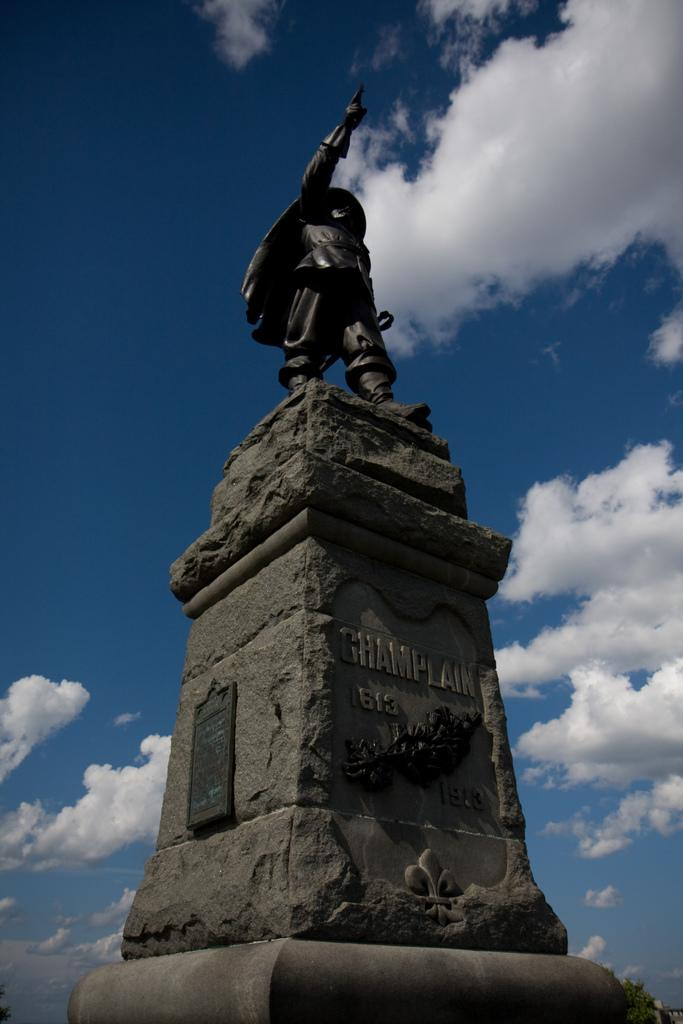What is the main subject in the center of the image? There is a statue in the center of the image. What can be seen in the background of the image? There is a sky visible in the background of the image. What is the condition of the sky in the image? There are clouds in the sky. How does the rainstorm affect the statue in the image? There is no rainstorm present in the image; it only shows a statue with clouds in the sky. 